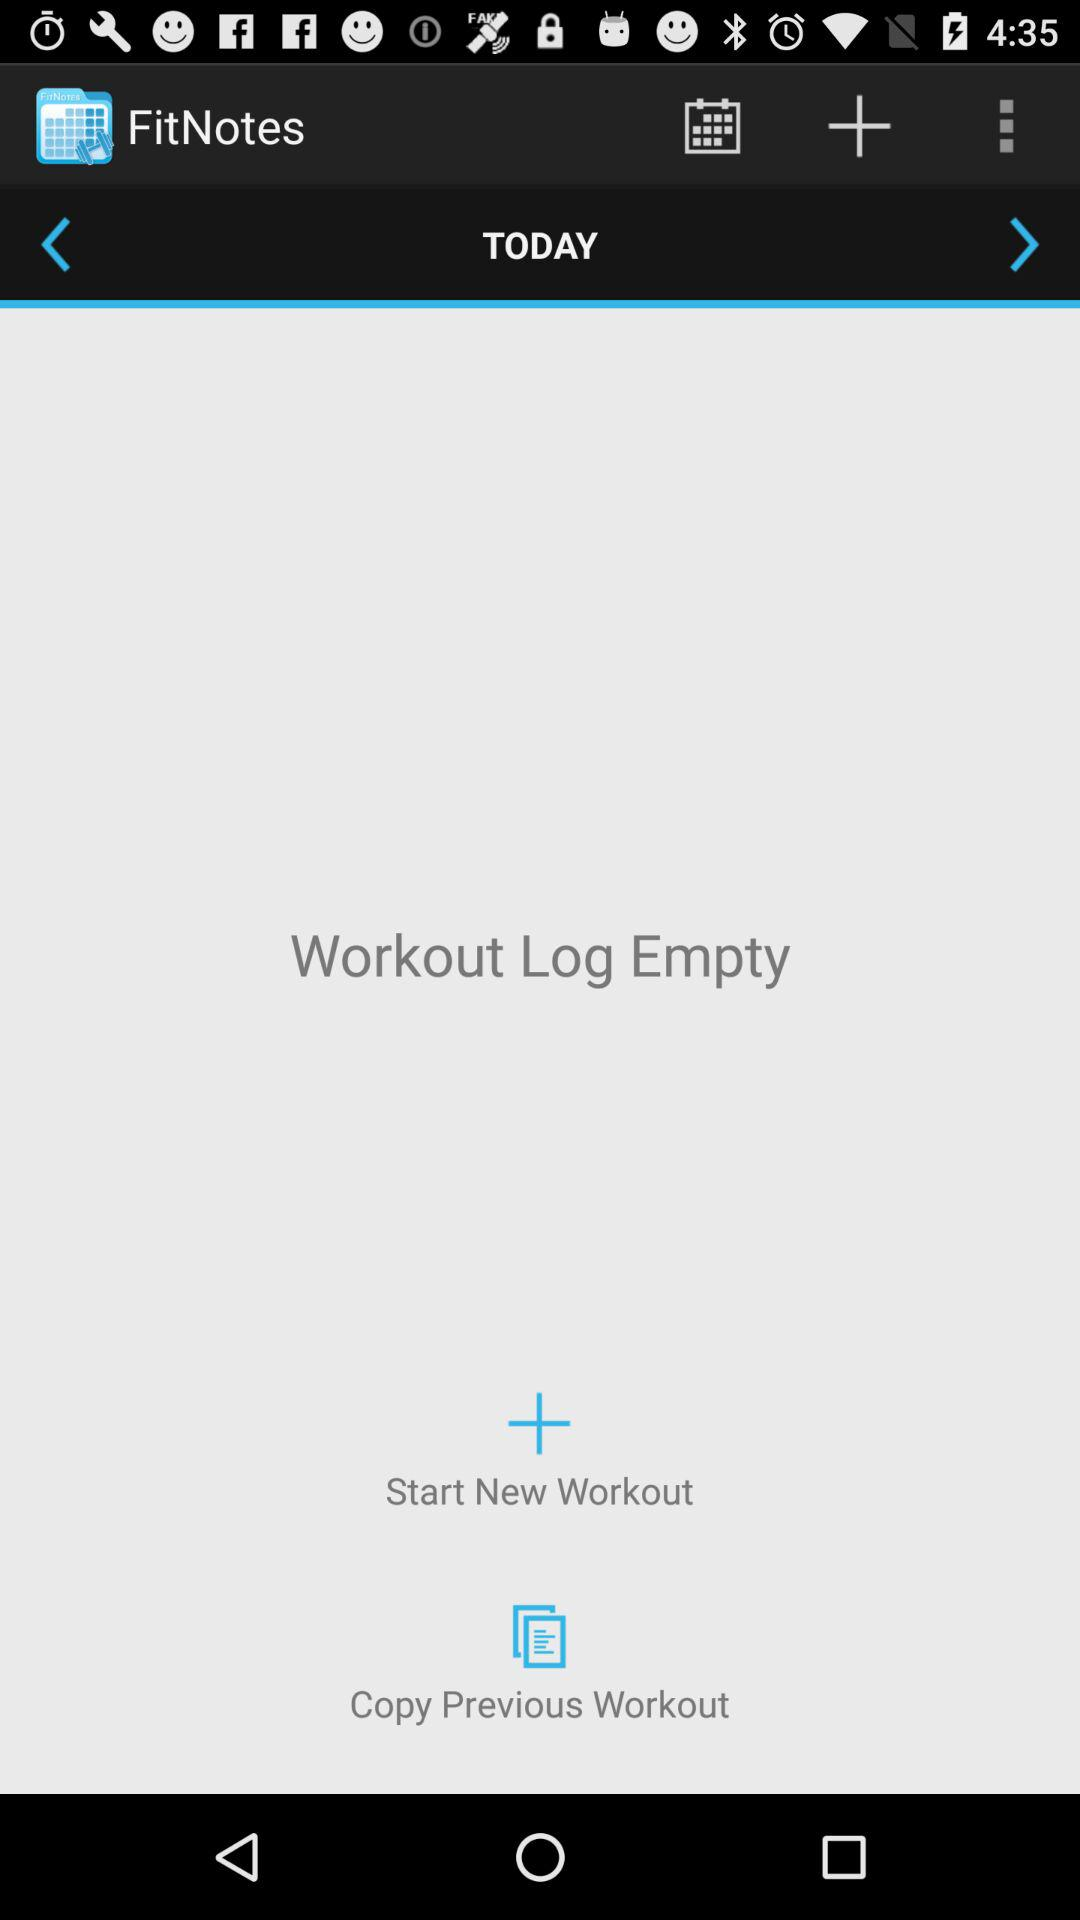Which day is selected? The selected day is today. 